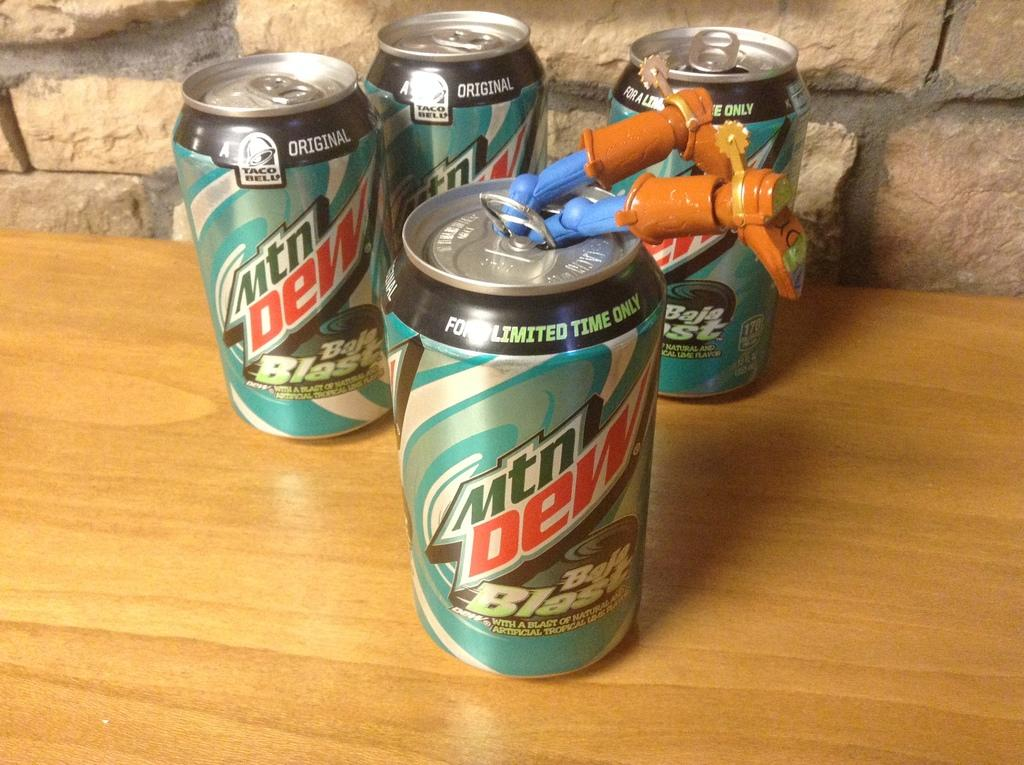<image>
Provide a brief description of the given image. four aluminum cans of mtn dew baja blast drinks 